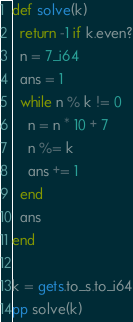<code> <loc_0><loc_0><loc_500><loc_500><_Crystal_>def solve(k)
  return -1 if k.even?
  n = 7_i64
  ans = 1
  while n % k != 0
    n = n * 10 + 7
    n %= k
    ans += 1
  end
  ans
end

k = gets.to_s.to_i64
pp solve(k)</code> 